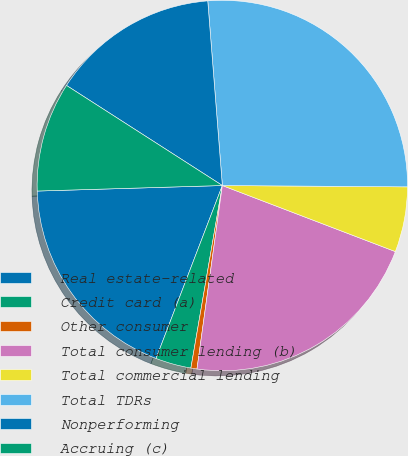<chart> <loc_0><loc_0><loc_500><loc_500><pie_chart><fcel>Real estate-related<fcel>Credit card (a)<fcel>Other consumer<fcel>Total consumer lending (b)<fcel>Total commercial lending<fcel>Total TDRs<fcel>Nonperforming<fcel>Accruing (c)<nl><fcel>18.7%<fcel>3.11%<fcel>0.53%<fcel>21.38%<fcel>5.69%<fcel>26.37%<fcel>14.66%<fcel>9.56%<nl></chart> 